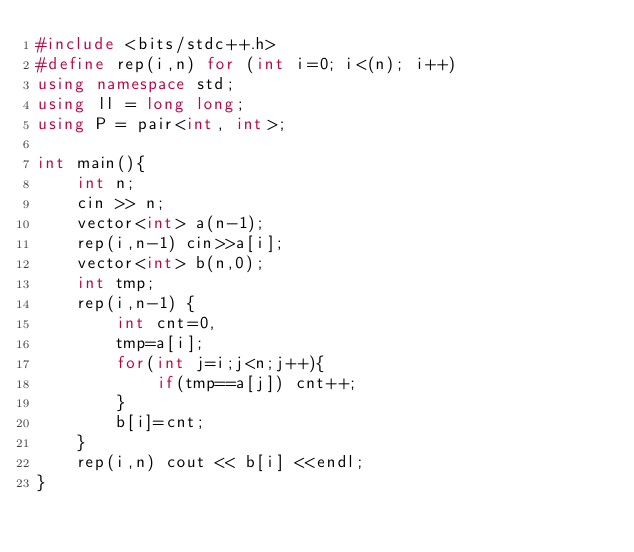<code> <loc_0><loc_0><loc_500><loc_500><_C++_>#include <bits/stdc++.h>
#define rep(i,n) for (int i=0; i<(n); i++)
using namespace std;
using ll = long long;
using P = pair<int, int>;

int main(){
    int n;
    cin >> n;
    vector<int> a(n-1);
    rep(i,n-1) cin>>a[i];
    vector<int> b(n,0);
    int tmp;
    rep(i,n-1) {
        int cnt=0,
        tmp=a[i];
        for(int j=i;j<n;j++){
            if(tmp==a[j]) cnt++;
        }
        b[i]=cnt;
    }
    rep(i,n) cout << b[i] <<endl;
}</code> 